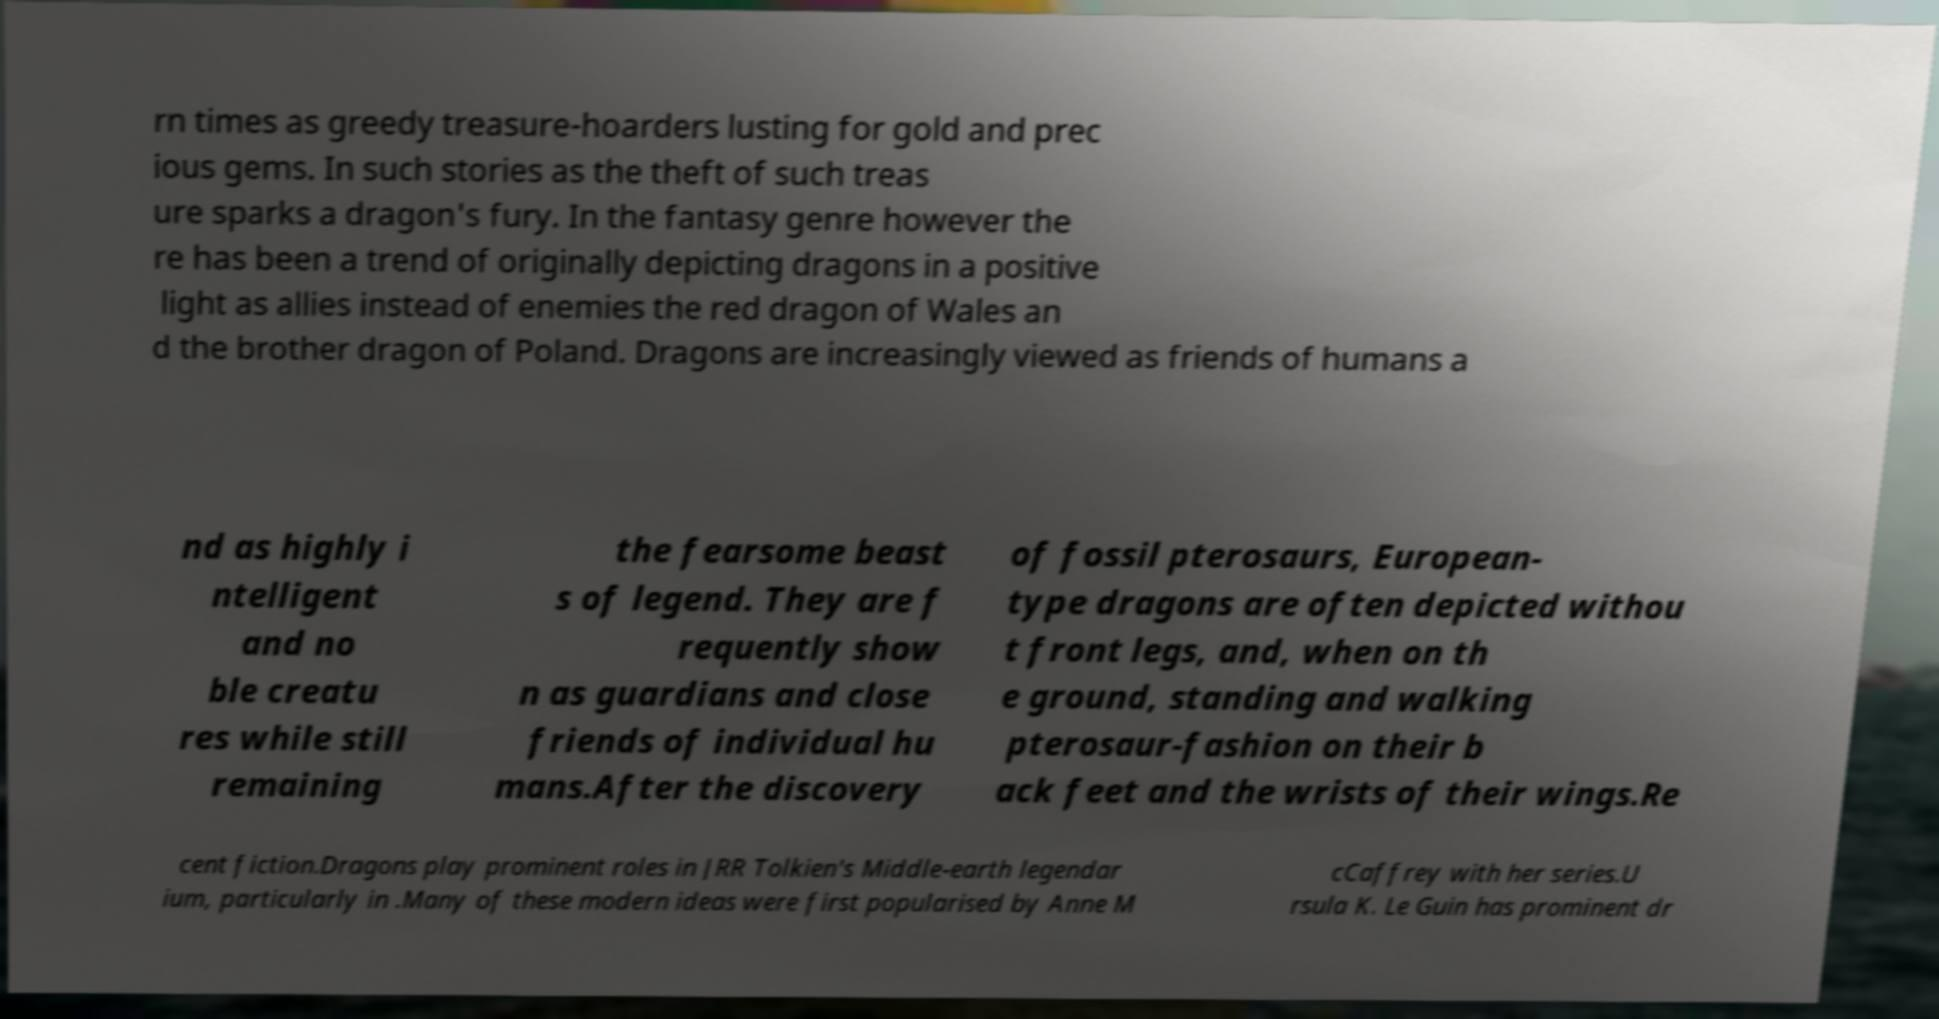Please identify and transcribe the text found in this image. rn times as greedy treasure-hoarders lusting for gold and prec ious gems. In such stories as the theft of such treas ure sparks a dragon's fury. In the fantasy genre however the re has been a trend of originally depicting dragons in a positive light as allies instead of enemies the red dragon of Wales an d the brother dragon of Poland. Dragons are increasingly viewed as friends of humans a nd as highly i ntelligent and no ble creatu res while still remaining the fearsome beast s of legend. They are f requently show n as guardians and close friends of individual hu mans.After the discovery of fossil pterosaurs, European- type dragons are often depicted withou t front legs, and, when on th e ground, standing and walking pterosaur-fashion on their b ack feet and the wrists of their wings.Re cent fiction.Dragons play prominent roles in JRR Tolkien's Middle-earth legendar ium, particularly in .Many of these modern ideas were first popularised by Anne M cCaffrey with her series.U rsula K. Le Guin has prominent dr 